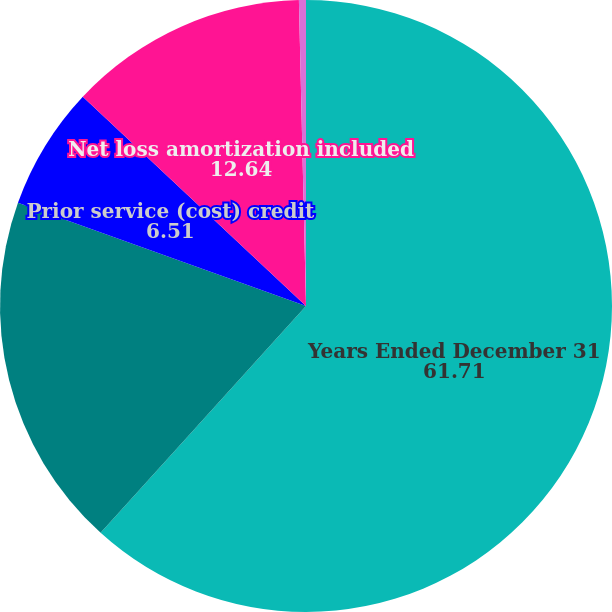Convert chart to OTSL. <chart><loc_0><loc_0><loc_500><loc_500><pie_chart><fcel>Years Ended December 31<fcel>Net gain (loss) arising during<fcel>Prior service (cost) credit<fcel>Net loss amortization included<fcel>Prior service cost (credit)<nl><fcel>61.71%<fcel>18.77%<fcel>6.51%<fcel>12.64%<fcel>0.37%<nl></chart> 